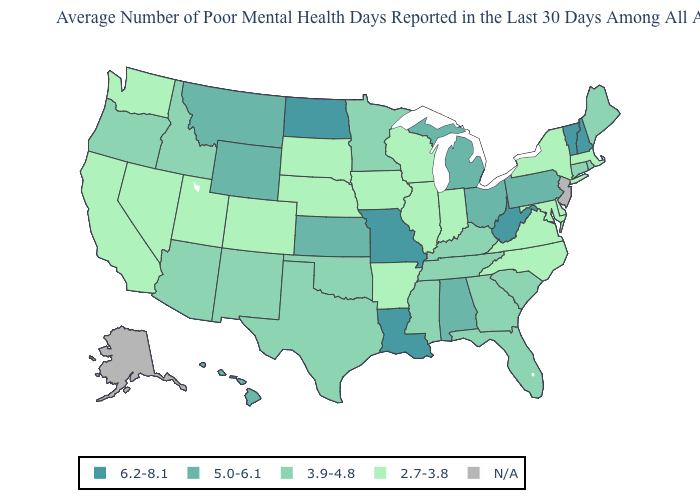Which states have the highest value in the USA?
Short answer required. Louisiana, Missouri, New Hampshire, North Dakota, Vermont, West Virginia. Among the states that border Louisiana , does Texas have the highest value?
Short answer required. Yes. What is the value of Colorado?
Be succinct. 2.7-3.8. Name the states that have a value in the range N/A?
Short answer required. Alaska, New Jersey. Name the states that have a value in the range 3.9-4.8?
Answer briefly. Arizona, Connecticut, Florida, Georgia, Idaho, Kentucky, Maine, Minnesota, Mississippi, New Mexico, Oklahoma, Oregon, Rhode Island, South Carolina, Tennessee, Texas. What is the value of Maine?
Concise answer only. 3.9-4.8. Name the states that have a value in the range 2.7-3.8?
Give a very brief answer. Arkansas, California, Colorado, Delaware, Illinois, Indiana, Iowa, Maryland, Massachusetts, Nebraska, Nevada, New York, North Carolina, South Dakota, Utah, Virginia, Washington, Wisconsin. Name the states that have a value in the range 6.2-8.1?
Short answer required. Louisiana, Missouri, New Hampshire, North Dakota, Vermont, West Virginia. Does Missouri have the highest value in the USA?
Write a very short answer. Yes. Among the states that border Pennsylvania , does Ohio have the highest value?
Answer briefly. No. Name the states that have a value in the range 5.0-6.1?
Short answer required. Alabama, Hawaii, Kansas, Michigan, Montana, Ohio, Pennsylvania, Wyoming. What is the lowest value in the MidWest?
Answer briefly. 2.7-3.8. Name the states that have a value in the range 2.7-3.8?
Be succinct. Arkansas, California, Colorado, Delaware, Illinois, Indiana, Iowa, Maryland, Massachusetts, Nebraska, Nevada, New York, North Carolina, South Dakota, Utah, Virginia, Washington, Wisconsin. Is the legend a continuous bar?
Concise answer only. No. What is the value of Missouri?
Concise answer only. 6.2-8.1. 